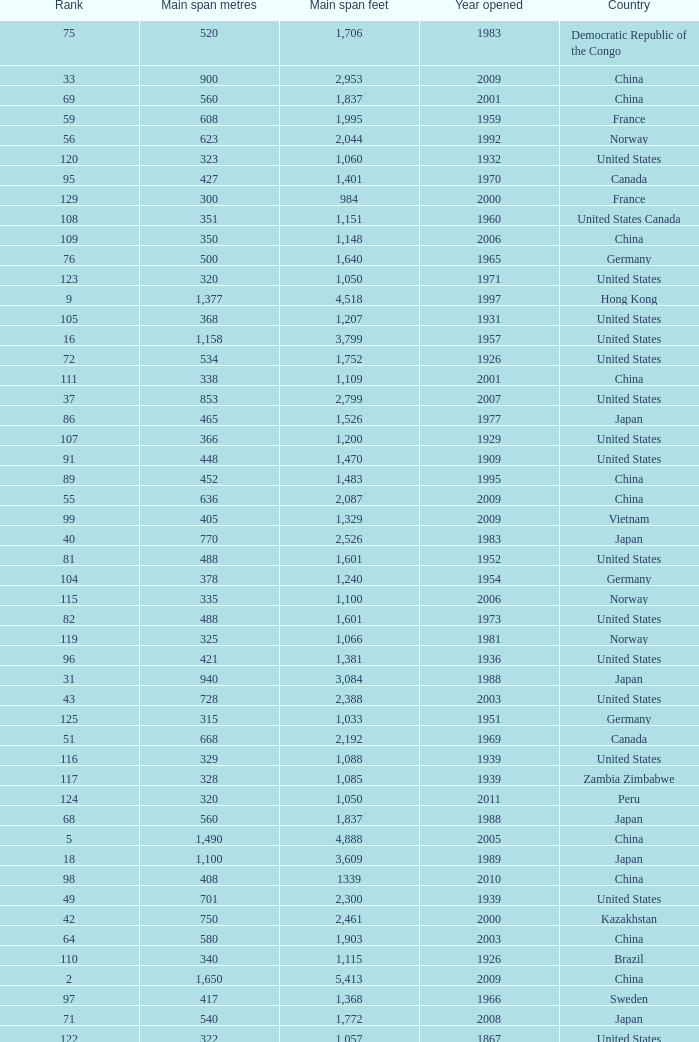What is the main span in feet from a year of 2009 or more recent with a rank less than 94 and 1,310 main span metres? 4298.0. 